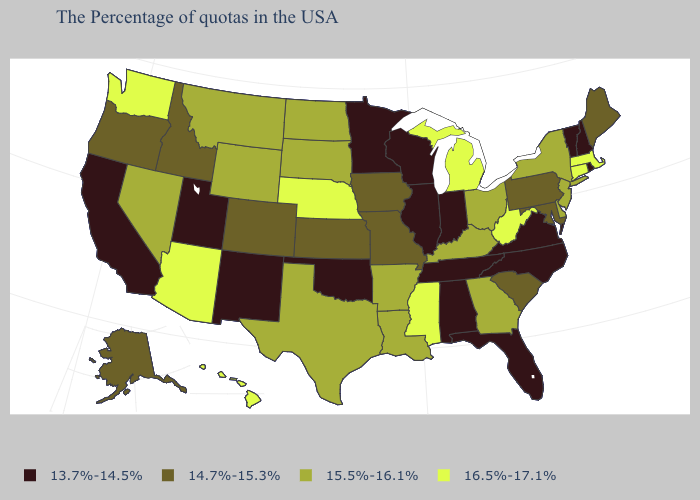Among the states that border Pennsylvania , which have the highest value?
Concise answer only. West Virginia. Name the states that have a value in the range 15.5%-16.1%?
Keep it brief. New York, New Jersey, Delaware, Ohio, Georgia, Kentucky, Louisiana, Arkansas, Texas, South Dakota, North Dakota, Wyoming, Montana, Nevada. Among the states that border Oregon , does Washington have the highest value?
Quick response, please. Yes. Name the states that have a value in the range 13.7%-14.5%?
Write a very short answer. Rhode Island, New Hampshire, Vermont, Virginia, North Carolina, Florida, Indiana, Alabama, Tennessee, Wisconsin, Illinois, Minnesota, Oklahoma, New Mexico, Utah, California. Which states have the highest value in the USA?
Short answer required. Massachusetts, Connecticut, West Virginia, Michigan, Mississippi, Nebraska, Arizona, Washington, Hawaii. Does the first symbol in the legend represent the smallest category?
Quick response, please. Yes. What is the value of Minnesota?
Write a very short answer. 13.7%-14.5%. What is the value of Colorado?
Be succinct. 14.7%-15.3%. Name the states that have a value in the range 15.5%-16.1%?
Concise answer only. New York, New Jersey, Delaware, Ohio, Georgia, Kentucky, Louisiana, Arkansas, Texas, South Dakota, North Dakota, Wyoming, Montana, Nevada. How many symbols are there in the legend?
Concise answer only. 4. Among the states that border Wyoming , does Montana have the lowest value?
Quick response, please. No. How many symbols are there in the legend?
Answer briefly. 4. Which states hav the highest value in the West?
Be succinct. Arizona, Washington, Hawaii. Among the states that border Indiana , which have the lowest value?
Write a very short answer. Illinois. Which states have the lowest value in the USA?
Give a very brief answer. Rhode Island, New Hampshire, Vermont, Virginia, North Carolina, Florida, Indiana, Alabama, Tennessee, Wisconsin, Illinois, Minnesota, Oklahoma, New Mexico, Utah, California. 